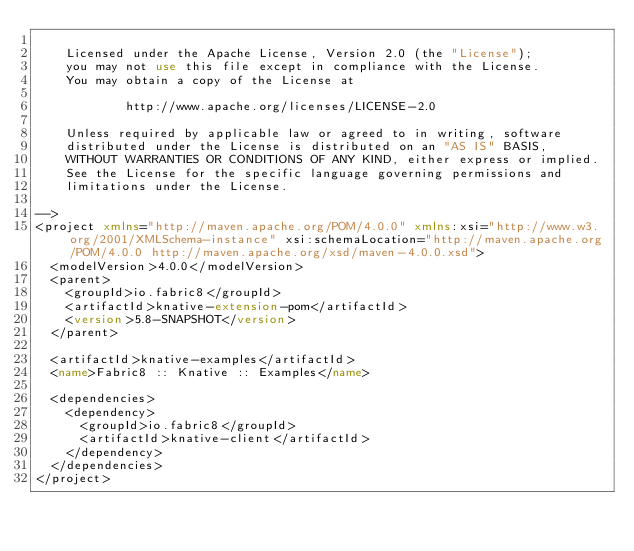Convert code to text. <code><loc_0><loc_0><loc_500><loc_500><_XML_>
    Licensed under the Apache License, Version 2.0 (the "License");
    you may not use this file except in compliance with the License.
    You may obtain a copy of the License at

            http://www.apache.org/licenses/LICENSE-2.0

    Unless required by applicable law or agreed to in writing, software
    distributed under the License is distributed on an "AS IS" BASIS,
    WITHOUT WARRANTIES OR CONDITIONS OF ANY KIND, either express or implied.
    See the License for the specific language governing permissions and
    limitations under the License.

-->
<project xmlns="http://maven.apache.org/POM/4.0.0" xmlns:xsi="http://www.w3.org/2001/XMLSchema-instance" xsi:schemaLocation="http://maven.apache.org/POM/4.0.0 http://maven.apache.org/xsd/maven-4.0.0.xsd">
  <modelVersion>4.0.0</modelVersion>
  <parent>
    <groupId>io.fabric8</groupId>
    <artifactId>knative-extension-pom</artifactId>
    <version>5.8-SNAPSHOT</version>
  </parent>

  <artifactId>knative-examples</artifactId>
  <name>Fabric8 :: Knative :: Examples</name>

  <dependencies>
    <dependency>
      <groupId>io.fabric8</groupId>
      <artifactId>knative-client</artifactId>
    </dependency>
  </dependencies>
</project>
</code> 